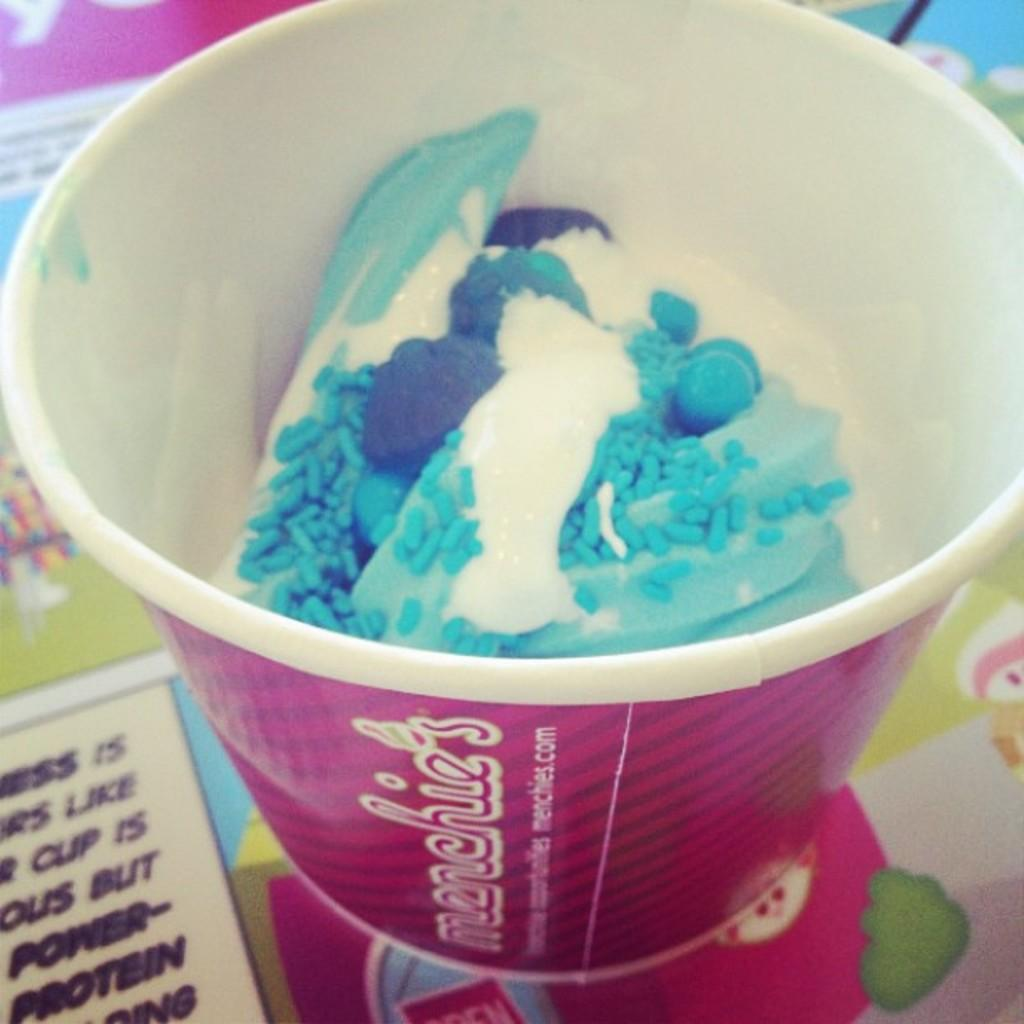What type of dessert is in the image? There is ice cream in a cup in the image. What can be seen on the cup? There is writing on the cup. What color is the cup? The cup is pink in color. How many legs can be seen on the ice cream in the image? The ice cream does not have legs, as it is a dessert and not a living creature. 